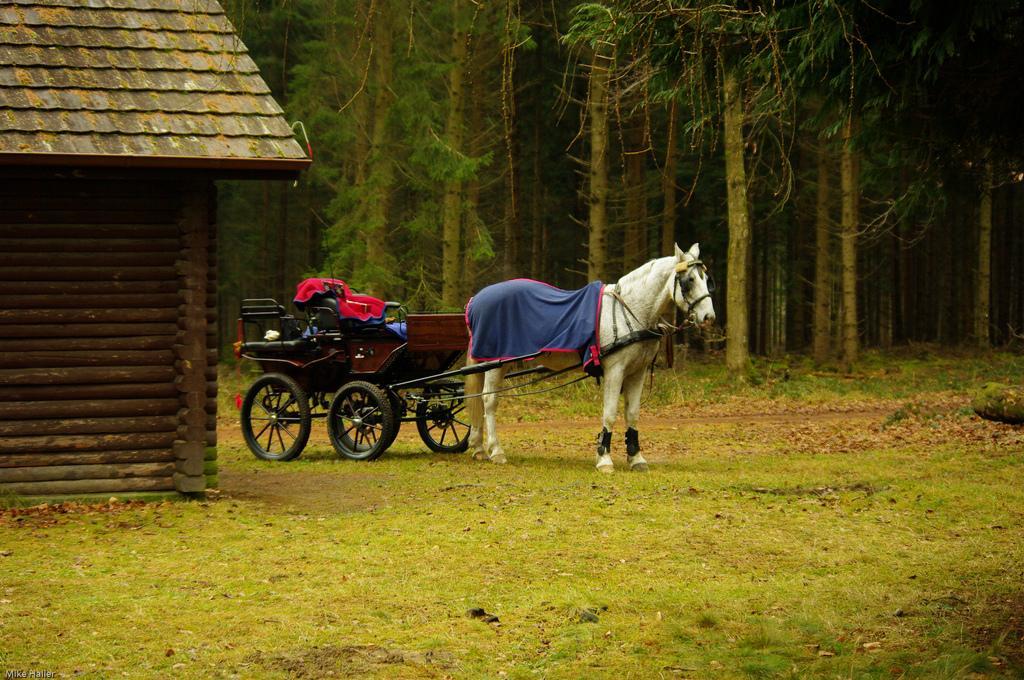How would you summarize this image in a sentence or two? As we can see in the image there is a white color horse, cart, house, grass and trees. 